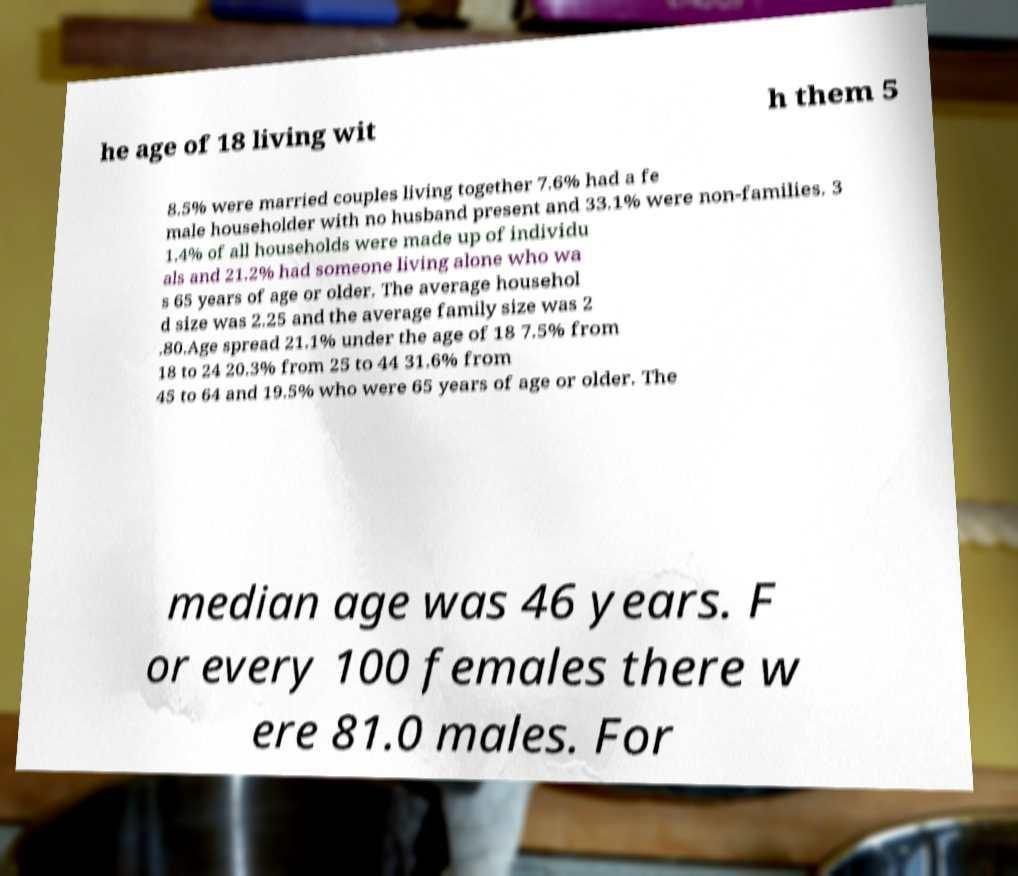What messages or text are displayed in this image? I need them in a readable, typed format. he age of 18 living wit h them 5 8.5% were married couples living together 7.6% had a fe male householder with no husband present and 33.1% were non-families. 3 1.4% of all households were made up of individu als and 21.2% had someone living alone who wa s 65 years of age or older. The average househol d size was 2.25 and the average family size was 2 .80.Age spread 21.1% under the age of 18 7.5% from 18 to 24 20.3% from 25 to 44 31.6% from 45 to 64 and 19.5% who were 65 years of age or older. The median age was 46 years. F or every 100 females there w ere 81.0 males. For 